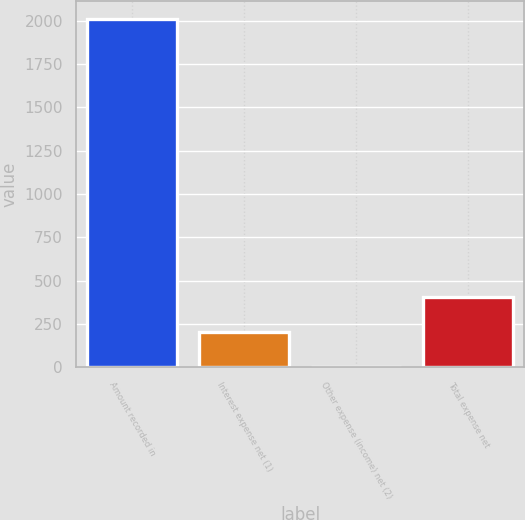Convert chart to OTSL. <chart><loc_0><loc_0><loc_500><loc_500><bar_chart><fcel>Amount recorded in<fcel>Interest expense net (1)<fcel>Other expense (income) net (2)<fcel>Total expense net<nl><fcel>2011<fcel>202.18<fcel>1.2<fcel>403.16<nl></chart> 